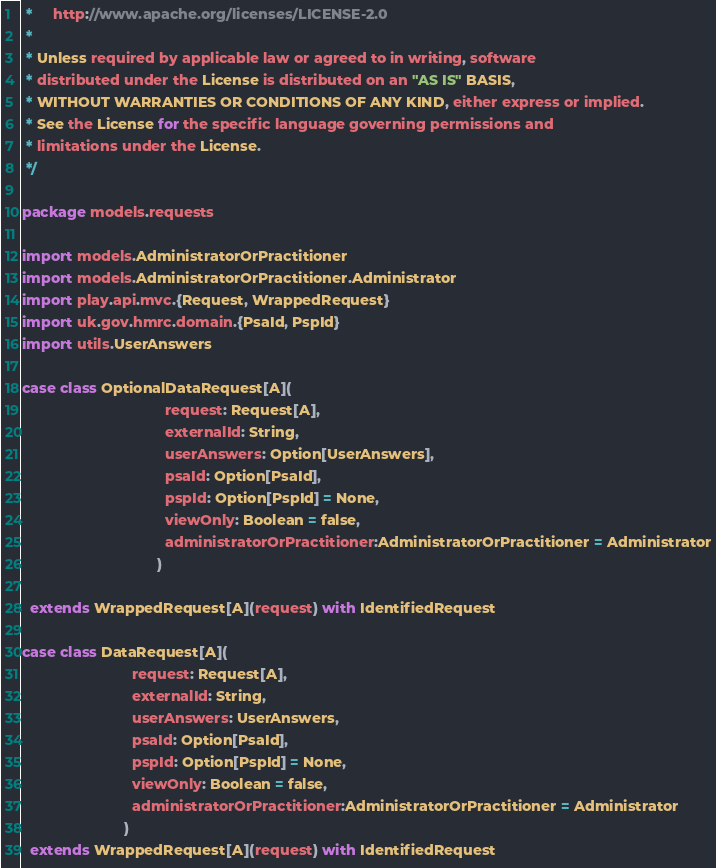<code> <loc_0><loc_0><loc_500><loc_500><_Scala_> *     http://www.apache.org/licenses/LICENSE-2.0
 *
 * Unless required by applicable law or agreed to in writing, software
 * distributed under the License is distributed on an "AS IS" BASIS,
 * WITHOUT WARRANTIES OR CONDITIONS OF ANY KIND, either express or implied.
 * See the License for the specific language governing permissions and
 * limitations under the License.
 */

package models.requests

import models.AdministratorOrPractitioner
import models.AdministratorOrPractitioner.Administrator
import play.api.mvc.{Request, WrappedRequest}
import uk.gov.hmrc.domain.{PsaId, PspId}
import utils.UserAnswers

case class OptionalDataRequest[A](
                                   request: Request[A],
                                   externalId: String,
                                   userAnswers: Option[UserAnswers],
                                   psaId: Option[PsaId],
                                   pspId: Option[PspId] = None,
                                   viewOnly: Boolean = false,
                                   administratorOrPractitioner:AdministratorOrPractitioner = Administrator
                                 )

  extends WrappedRequest[A](request) with IdentifiedRequest

case class DataRequest[A](
                           request: Request[A],
                           externalId: String,
                           userAnswers: UserAnswers,
                           psaId: Option[PsaId],
                           pspId: Option[PspId] = None,
                           viewOnly: Boolean = false,
                           administratorOrPractitioner:AdministratorOrPractitioner = Administrator
                         )
  extends WrappedRequest[A](request) with IdentifiedRequest
</code> 